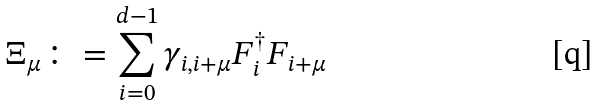<formula> <loc_0><loc_0><loc_500><loc_500>\Xi _ { \mu } \colon = \sum _ { i = 0 } ^ { d - 1 } \gamma _ { i , i + \mu } F _ { i } ^ { \dagger } F _ { i + \mu }</formula> 